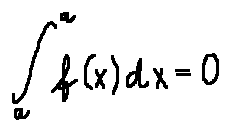<formula> <loc_0><loc_0><loc_500><loc_500>\int \lim i t s _ { a } ^ { a } f ( x ) d x = 0</formula> 